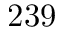Convert formula to latex. <formula><loc_0><loc_0><loc_500><loc_500>2 3 9</formula> 